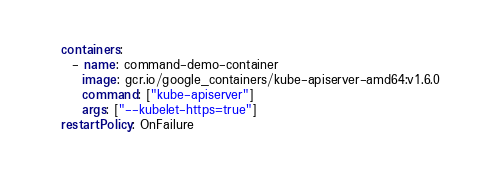Convert code to text. <code><loc_0><loc_0><loc_500><loc_500><_YAML_>  containers:
    - name: command-demo-container
      image: gcr.io/google_containers/kube-apiserver-amd64:v1.6.0
      command: ["kube-apiserver"]
      args: ["--kubelet-https=true"]
  restartPolicy: OnFailure
</code> 